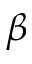<formula> <loc_0><loc_0><loc_500><loc_500>\beta</formula> 